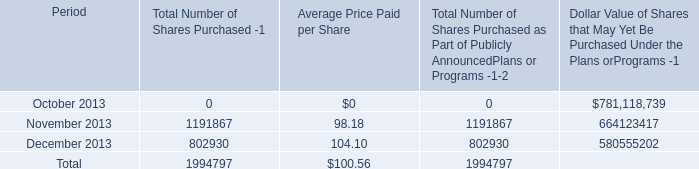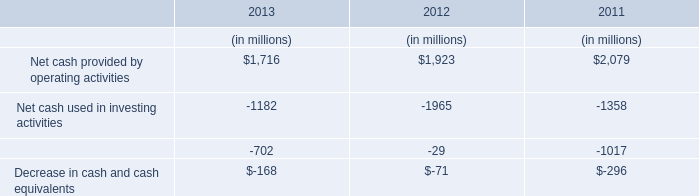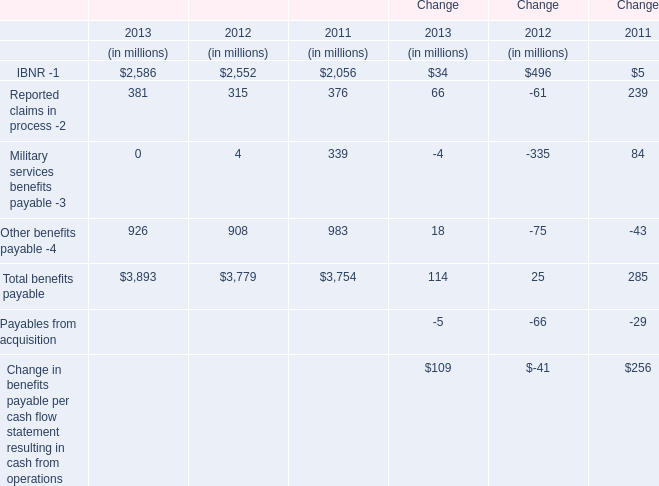What's the total amount of the Reported claims in process -2 in the years where Net cash provided by operating activities is greater than 0? (in million) 
Computations: ((381 + 315) + 376)
Answer: 1072.0. 